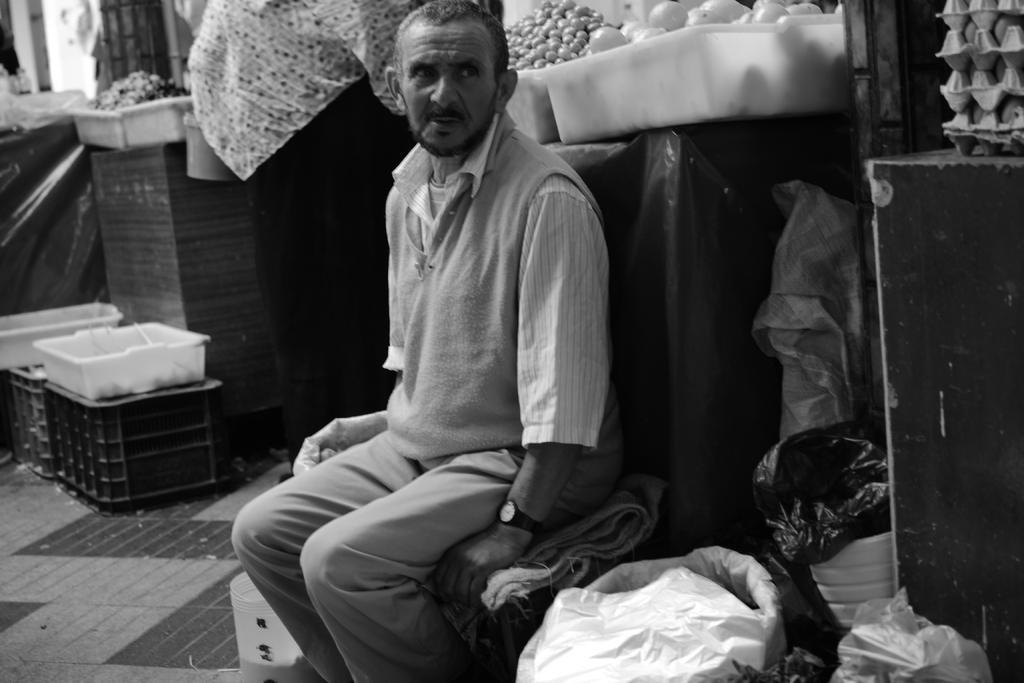In one or two sentences, can you explain what this image depicts? It is a black and white image,there is a man sitting on some tool,around the man there are onions,eggs and some other items and looks like a store. 